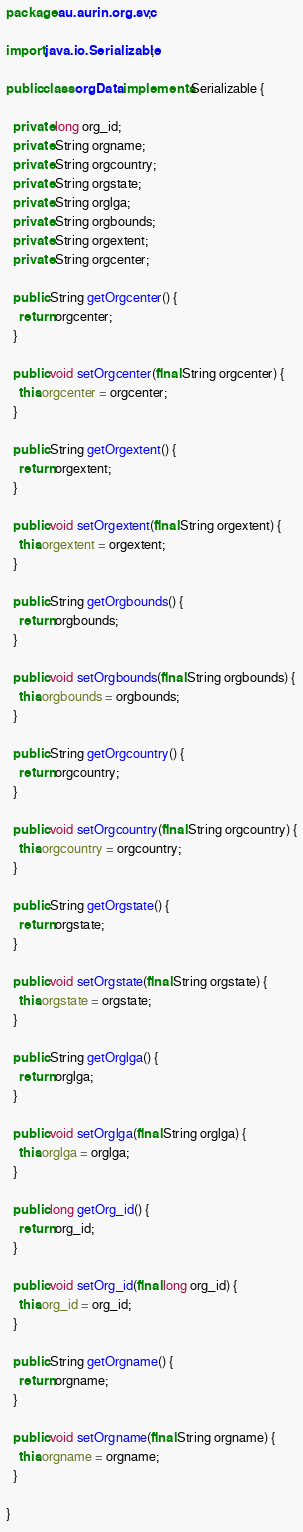<code> <loc_0><loc_0><loc_500><loc_500><_Java_>package au.aurin.org.svc;

import java.io.Serializable;

public class orgData implements Serializable {

  private long org_id;
  private String orgname;
  private String orgcountry;
  private String orgstate;
  private String orglga;
  private String orgbounds;
  private String orgextent;
  private String orgcenter;

  public String getOrgcenter() {
    return orgcenter;
  }

  public void setOrgcenter(final String orgcenter) {
    this.orgcenter = orgcenter;
  }

  public String getOrgextent() {
    return orgextent;
  }

  public void setOrgextent(final String orgextent) {
    this.orgextent = orgextent;
  }

  public String getOrgbounds() {
    return orgbounds;
  }

  public void setOrgbounds(final String orgbounds) {
    this.orgbounds = orgbounds;
  }

  public String getOrgcountry() {
    return orgcountry;
  }

  public void setOrgcountry(final String orgcountry) {
    this.orgcountry = orgcountry;
  }

  public String getOrgstate() {
    return orgstate;
  }

  public void setOrgstate(final String orgstate) {
    this.orgstate = orgstate;
  }

  public String getOrglga() {
    return orglga;
  }

  public void setOrglga(final String orglga) {
    this.orglga = orglga;
  }

  public long getOrg_id() {
    return org_id;
  }

  public void setOrg_id(final long org_id) {
    this.org_id = org_id;
  }

  public String getOrgname() {
    return orgname;
  }

  public void setOrgname(final String orgname) {
    this.orgname = orgname;
  }

}
</code> 